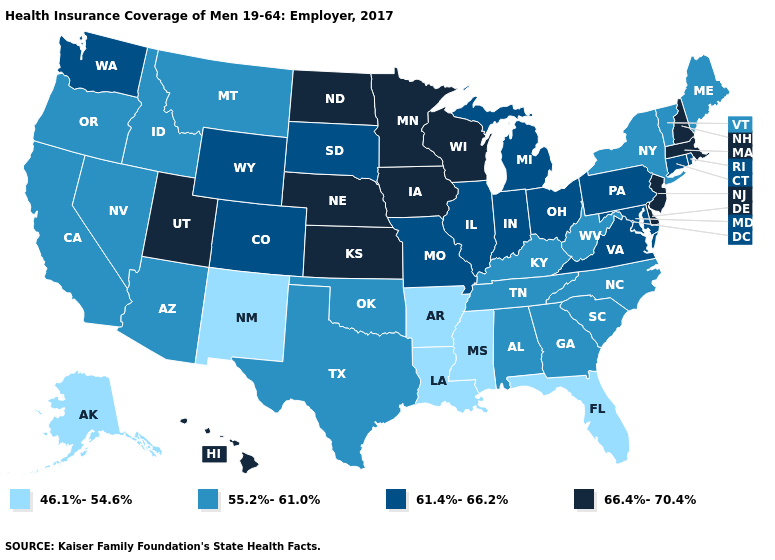What is the value of Vermont?
Concise answer only. 55.2%-61.0%. Does the map have missing data?
Quick response, please. No. What is the value of Wisconsin?
Answer briefly. 66.4%-70.4%. What is the value of Indiana?
Short answer required. 61.4%-66.2%. Does Montana have the highest value in the West?
Quick response, please. No. What is the value of Vermont?
Concise answer only. 55.2%-61.0%. Name the states that have a value in the range 46.1%-54.6%?
Quick response, please. Alaska, Arkansas, Florida, Louisiana, Mississippi, New Mexico. Does Minnesota have the highest value in the USA?
Give a very brief answer. Yes. Name the states that have a value in the range 61.4%-66.2%?
Short answer required. Colorado, Connecticut, Illinois, Indiana, Maryland, Michigan, Missouri, Ohio, Pennsylvania, Rhode Island, South Dakota, Virginia, Washington, Wyoming. What is the highest value in states that border South Dakota?
Be succinct. 66.4%-70.4%. Which states have the lowest value in the USA?
Be succinct. Alaska, Arkansas, Florida, Louisiana, Mississippi, New Mexico. Which states have the highest value in the USA?
Give a very brief answer. Delaware, Hawaii, Iowa, Kansas, Massachusetts, Minnesota, Nebraska, New Hampshire, New Jersey, North Dakota, Utah, Wisconsin. Name the states that have a value in the range 61.4%-66.2%?
Write a very short answer. Colorado, Connecticut, Illinois, Indiana, Maryland, Michigan, Missouri, Ohio, Pennsylvania, Rhode Island, South Dakota, Virginia, Washington, Wyoming. Among the states that border Maryland , does West Virginia have the lowest value?
Keep it brief. Yes. What is the value of Virginia?
Quick response, please. 61.4%-66.2%. 